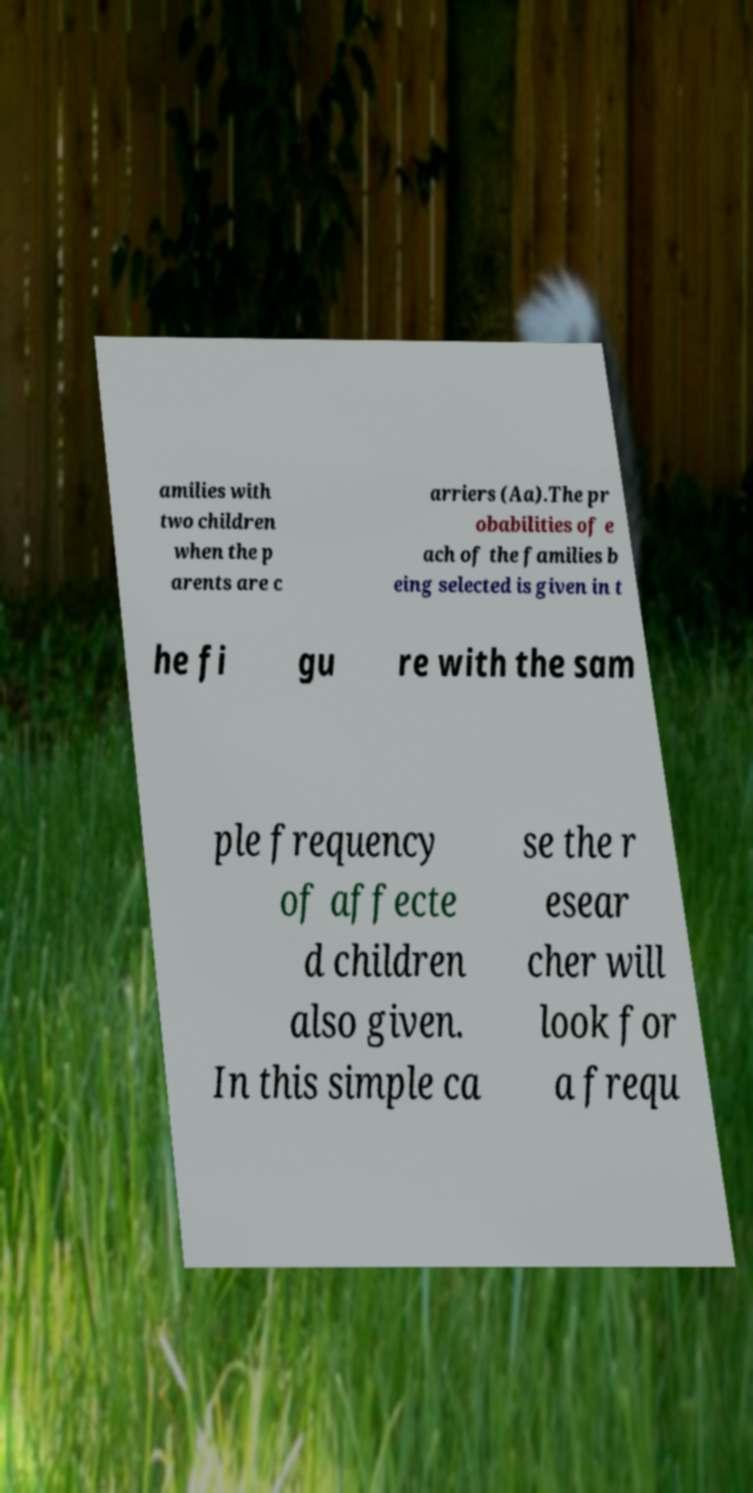Please read and relay the text visible in this image. What does it say? amilies with two children when the p arents are c arriers (Aa).The pr obabilities of e ach of the families b eing selected is given in t he fi gu re with the sam ple frequency of affecte d children also given. In this simple ca se the r esear cher will look for a frequ 